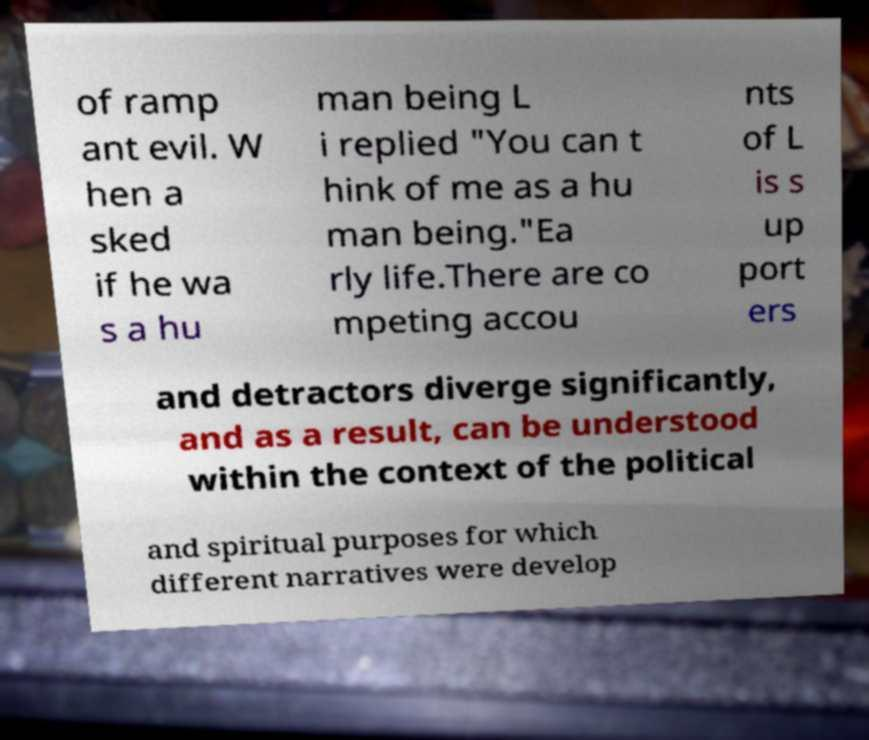Please identify and transcribe the text found in this image. of ramp ant evil. W hen a sked if he wa s a hu man being L i replied "You can t hink of me as a hu man being."Ea rly life.There are co mpeting accou nts of L is s up port ers and detractors diverge significantly, and as a result, can be understood within the context of the political and spiritual purposes for which different narratives were develop 